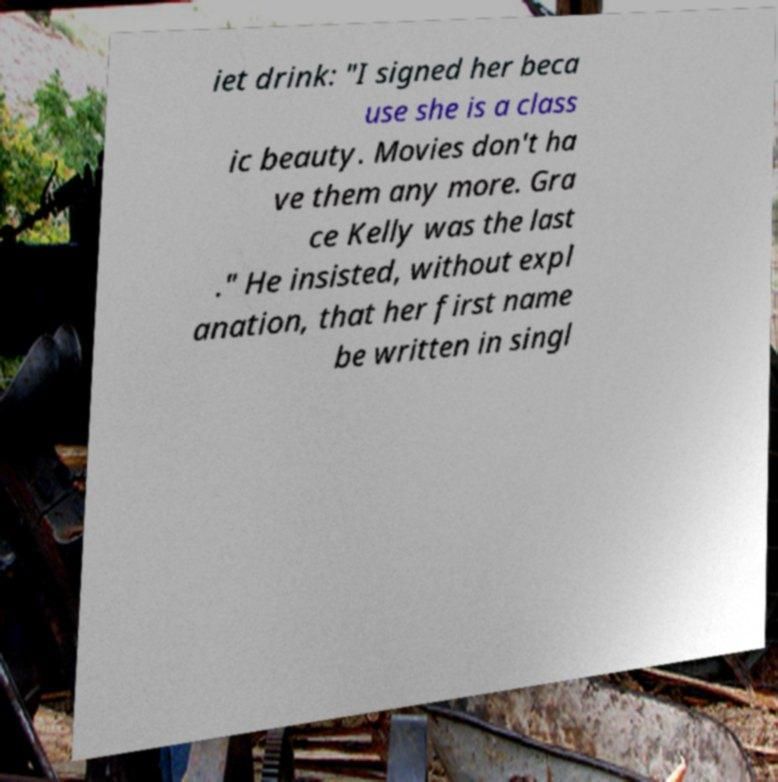There's text embedded in this image that I need extracted. Can you transcribe it verbatim? iet drink: "I signed her beca use she is a class ic beauty. Movies don't ha ve them any more. Gra ce Kelly was the last ." He insisted, without expl anation, that her first name be written in singl 